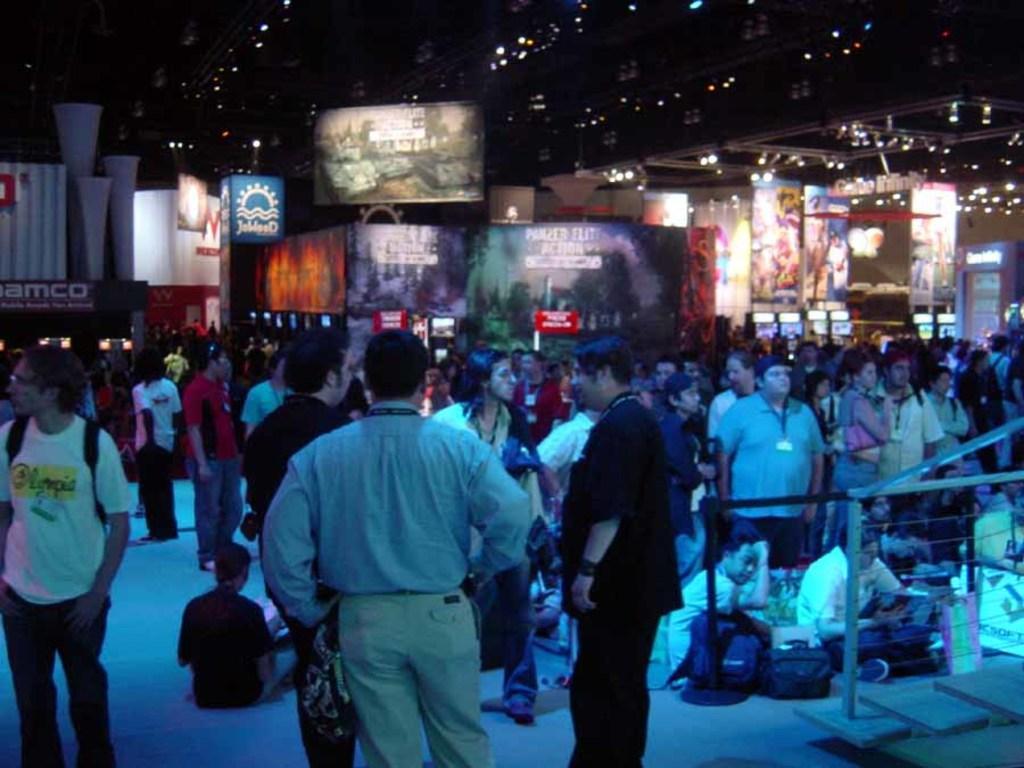In one or two sentences, can you explain what this image depicts? In the picture I can see group of people among them some are sitting and some are standing on the ground. In the background I can see banners, lights and some other objects. 